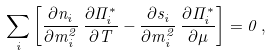Convert formula to latex. <formula><loc_0><loc_0><loc_500><loc_500>\sum _ { i } \left [ \frac { \partial n _ { i } } { \partial m _ { i } ^ { 2 } } \, \frac { \partial \Pi _ { i } ^ { * } } { \partial T } - \frac { \partial s _ { i } } { \partial m _ { i } ^ { 2 } } \, \frac { \partial \Pi _ { i } ^ { * } } { \partial \mu } \right ] = 0 \, ,</formula> 